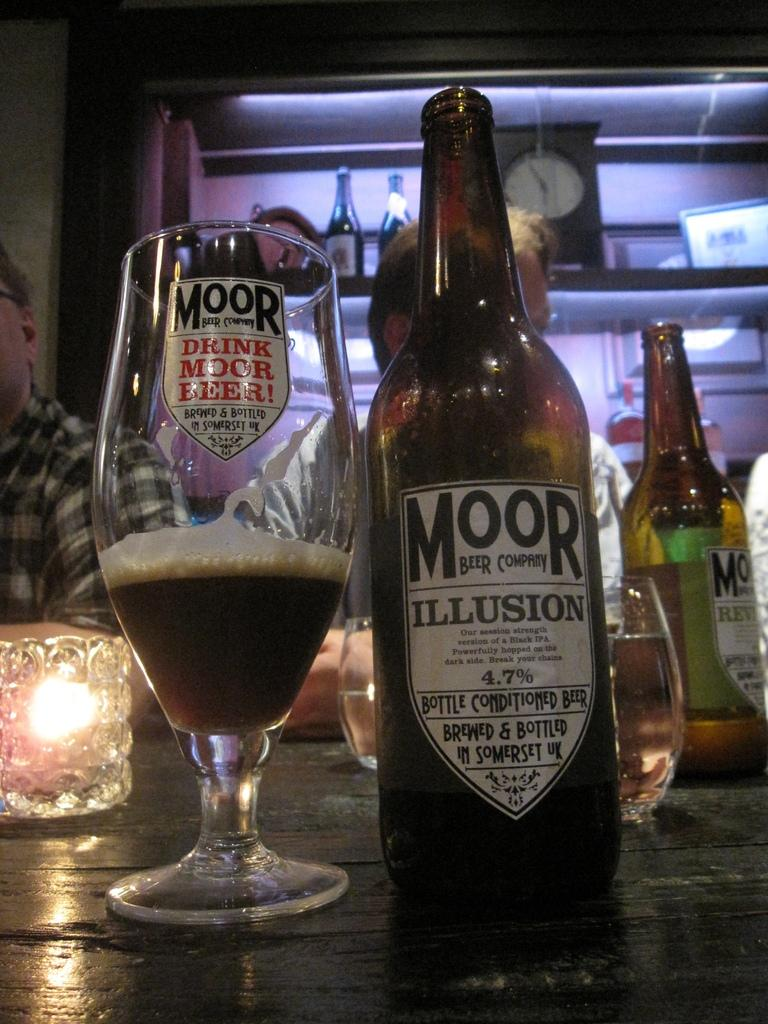Provide a one-sentence caption for the provided image. A bottle of Moor beer is next to a glass that has a pun about the company on it. 